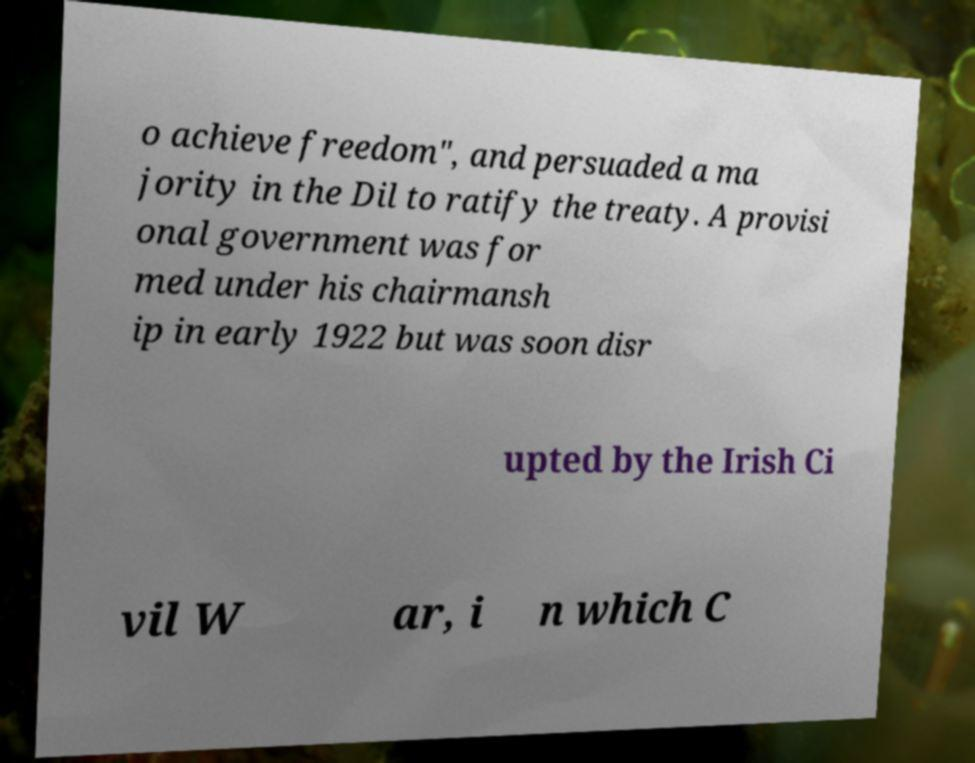For documentation purposes, I need the text within this image transcribed. Could you provide that? o achieve freedom", and persuaded a ma jority in the Dil to ratify the treaty. A provisi onal government was for med under his chairmansh ip in early 1922 but was soon disr upted by the Irish Ci vil W ar, i n which C 